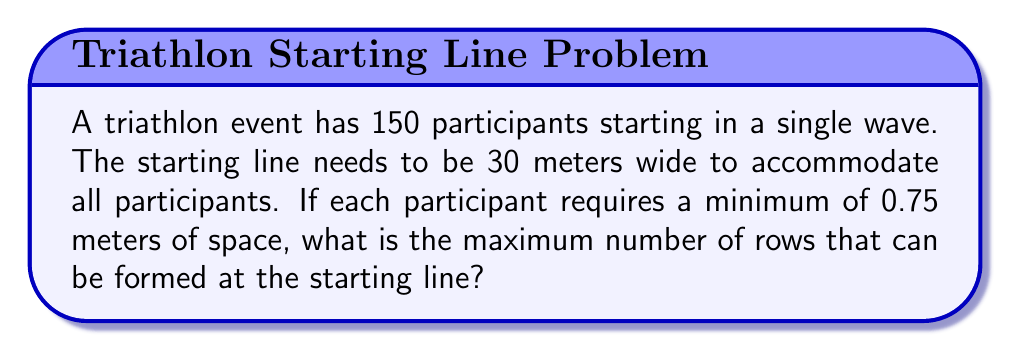Solve this math problem. Let's approach this step-by-step:

1. Calculate the number of participants that can fit in a single row:
   $$ \text{Participants per row} = \frac{\text{Width of starting line}}{\text{Space per participant}} $$
   $$ \text{Participants per row} = \frac{30 \text{ m}}{0.75 \text{ m/participant}} = 40 \text{ participants/row} $$

2. Calculate the number of rows needed:
   $$ \text{Number of rows} = \frac{\text{Total participants}}{\text{Participants per row}} $$
   $$ \text{Number of rows} = \frac{150}{40} = 3.75 $$

3. Since we can't have a fractional row, we need to round up to the nearest whole number:
   $$ \text{Maximum number of rows} = \lceil 3.75 \rceil = 4 $$

Therefore, the maximum number of rows that can be formed at the starting line is 4.
Answer: 4 rows 